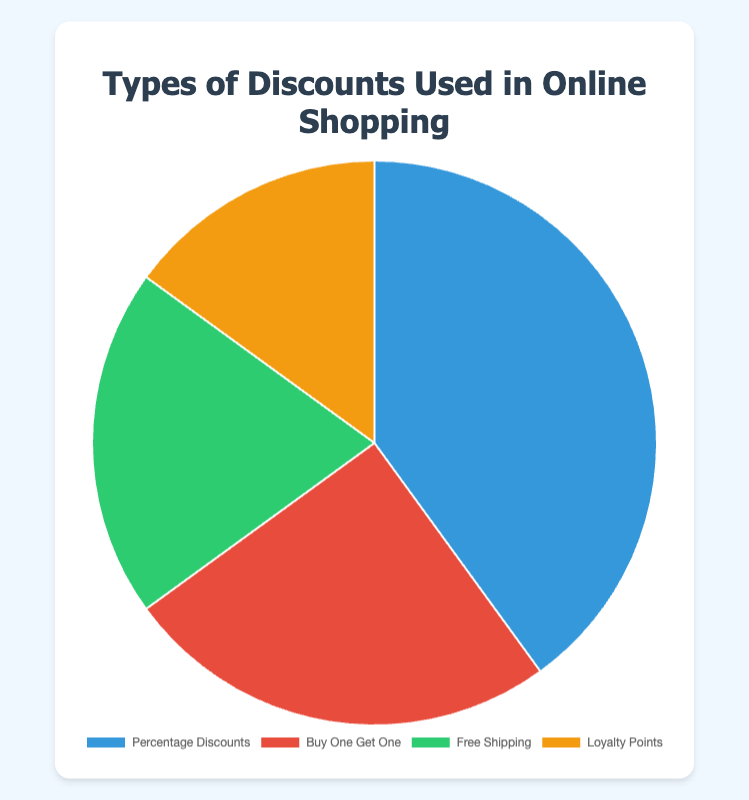What is the most common type of discount used in online shopping? The largest section of the pie chart represents 40% and is labeled as "Percentage Discounts". This indicates it is the most common discount used in online shopping.
Answer: Percentage Discounts Which type of discount is used the least? The smallest section of the pie chart represents 15% and is labeled as "Loyalty Points", indicating it is the least used discount type.
Answer: Loyalty Points How much more popular are "Percentage Discounts" compared to "Free Shipping"? "Percentage Discounts" account for 40% and "Free Shipping" accounts for 20%. The difference is 40% - 20% = 20%.
Answer: 20% What is the combined percentage of "Buy One Get One" and "Free Shipping"? "Buy One Get One" accounts for 25% and "Free Shipping" accounts for 20%. Their combined percentage is 25% + 20% = 45%.
Answer: 45% How does the popularity of "Loyalty Points" compare to "Buy One Get One"? "Loyalty Points" accounts for 15% and "Buy One Get One" accounts for 25%. Therefore, "Buy One Get One" is 25% - 15% = 10% more popular.
Answer: 10% Which two discount types together make up half of all discounts used? "Percentage Discounts" accounts for 40% and "Buy One Get One" accounts for 25%. When summed, 40% + 25% = 65%. Given this combination is over half, individually "Percentage Discounts" at 40% and "Free Shipping" at 20% together sum to 40% + 20% = 60%. Thus, the best combination under half is "Percentage Discounts" and "Free Shipping".
Answer: Percentage Discounts and Free Shipping Which section of the pie chart has the second largest percentage? The section labeled "Buy One Get One" represents 25%, which is the second largest after "Percentage Discounts" at 40%.
Answer: Buy One Get One What is the average percentage of the four discount types? Adding the percentages: 40% (Percentage Discounts) + 25% (Buy One Get One) + 20% (Free Shipping) + 15% (Loyalty Points) = 100%. Dividing by the number of discount types: 100% / 4 = 25%.
Answer: 25% If "Loyalty Points" were used an additional 5%, how would that change its ranking compared to other discounts? Currently, "Loyalty Points" are at 15%. Adding 5% makes it 20%, equal to "Free Shipping". It would change its ranking from the least used to be tied for the third most used.
Answer: Tied for third 